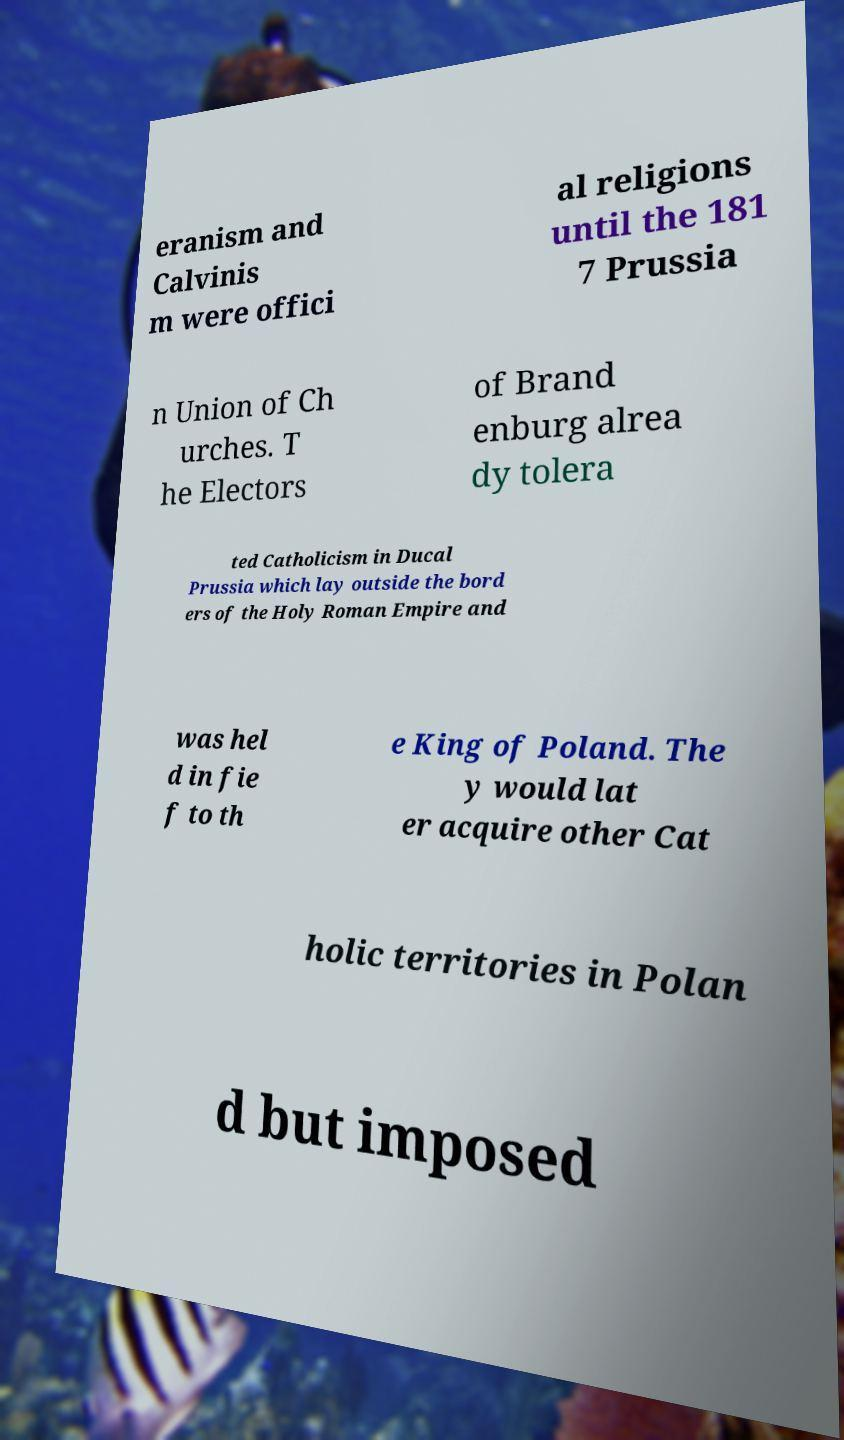Could you assist in decoding the text presented in this image and type it out clearly? eranism and Calvinis m were offici al religions until the 181 7 Prussia n Union of Ch urches. T he Electors of Brand enburg alrea dy tolera ted Catholicism in Ducal Prussia which lay outside the bord ers of the Holy Roman Empire and was hel d in fie f to th e King of Poland. The y would lat er acquire other Cat holic territories in Polan d but imposed 